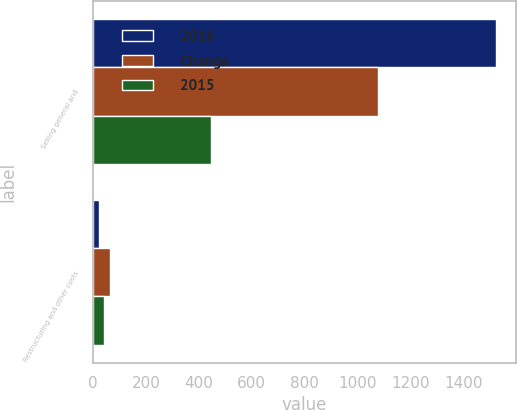Convert chart. <chart><loc_0><loc_0><loc_500><loc_500><stacked_bar_chart><ecel><fcel>Selling general and<fcel>Restructuring and other costs<nl><fcel>2016<fcel>1523<fcel>23.2<nl><fcel>Change<fcel>1077.3<fcel>64.7<nl><fcel>2015<fcel>445.7<fcel>41.5<nl></chart> 